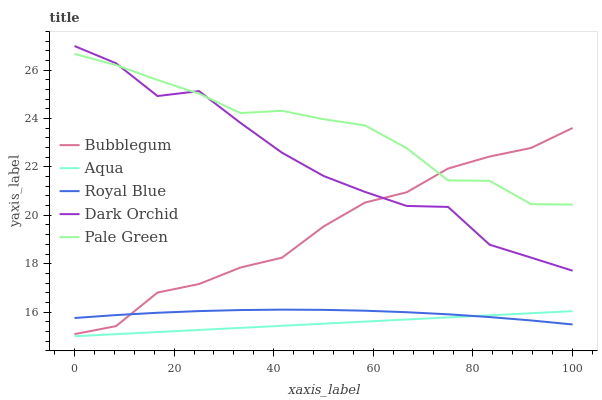Does Aqua have the minimum area under the curve?
Answer yes or no. Yes. Does Pale Green have the maximum area under the curve?
Answer yes or no. Yes. Does Pale Green have the minimum area under the curve?
Answer yes or no. No. Does Aqua have the maximum area under the curve?
Answer yes or no. No. Is Aqua the smoothest?
Answer yes or no. Yes. Is Dark Orchid the roughest?
Answer yes or no. Yes. Is Pale Green the smoothest?
Answer yes or no. No. Is Pale Green the roughest?
Answer yes or no. No. Does Aqua have the lowest value?
Answer yes or no. Yes. Does Pale Green have the lowest value?
Answer yes or no. No. Does Dark Orchid have the highest value?
Answer yes or no. Yes. Does Pale Green have the highest value?
Answer yes or no. No. Is Aqua less than Bubblegum?
Answer yes or no. Yes. Is Pale Green greater than Aqua?
Answer yes or no. Yes. Does Bubblegum intersect Dark Orchid?
Answer yes or no. Yes. Is Bubblegum less than Dark Orchid?
Answer yes or no. No. Is Bubblegum greater than Dark Orchid?
Answer yes or no. No. Does Aqua intersect Bubblegum?
Answer yes or no. No. 